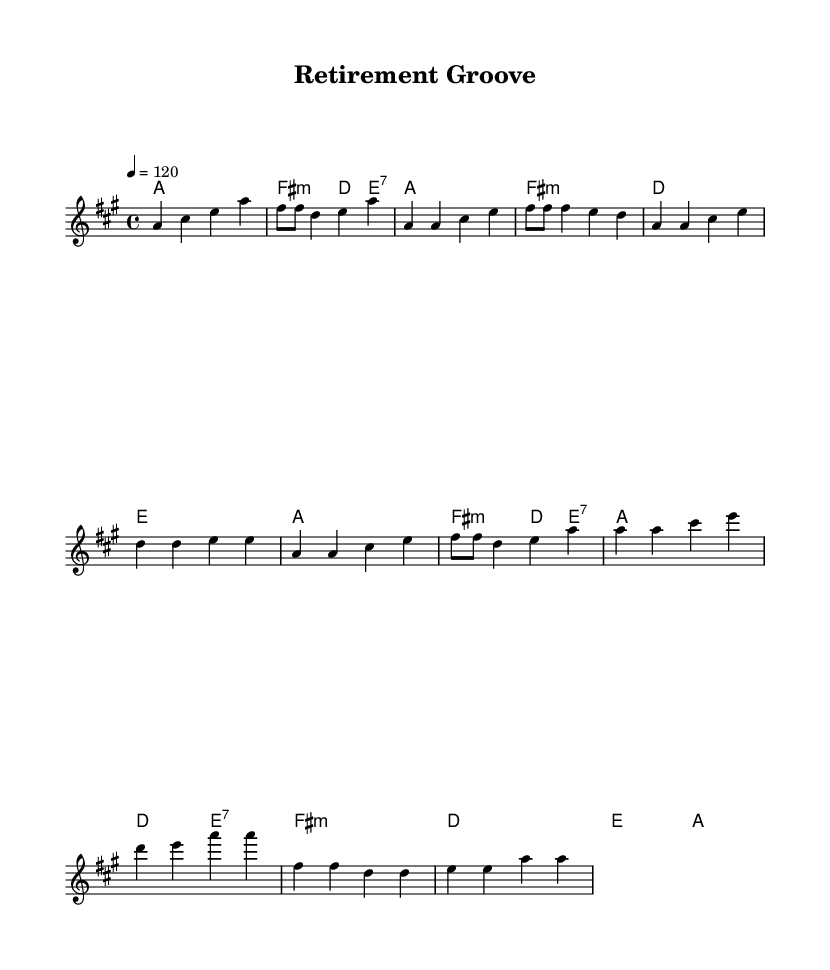What is the key signature of this music? The key signature is A major, which has three sharps (F#, C#, and G#). This can be identified from the 'key' directive line in the global section of the code.
Answer: A major What is the time signature of this music? The time signature is 4/4, which means there are four beats in each measure and the quarter note gets one beat. This is indicated in the global section of the code.
Answer: 4/4 What is the tempo marking for this music? The tempo marking is 120 beats per minute. This is indicated by the 'tempo' directive in the global section of the code.
Answer: 120 How many measures are in the chorus? There are four measures in the chorus as determined by counting the individual measures in the melodyChorus section. Each measure is separated by a bar line.
Answer: Four What type of lyrics are included in the sheet music? The lyrics express themes of relaxation and new beginnings in retirement. This is evident from the words in the verseWords and chorusWords sections.
Answer: Relaxation and new beginnings What is the unique characteristic of the music style represented in the sheet? The music is characterized by a funky disco style, which includes a groovy feel and upbeat tempo suitable for dancing. This style is apparent in the upbeat nature and tempo marking.
Answer: Funky disco What are the primary chords used in the verse? The primary chords used in the verse are A major, F# minor, D major, and E major, as indicated in the harmonyVerse section.
Answer: A major, F# minor, D major, E major 